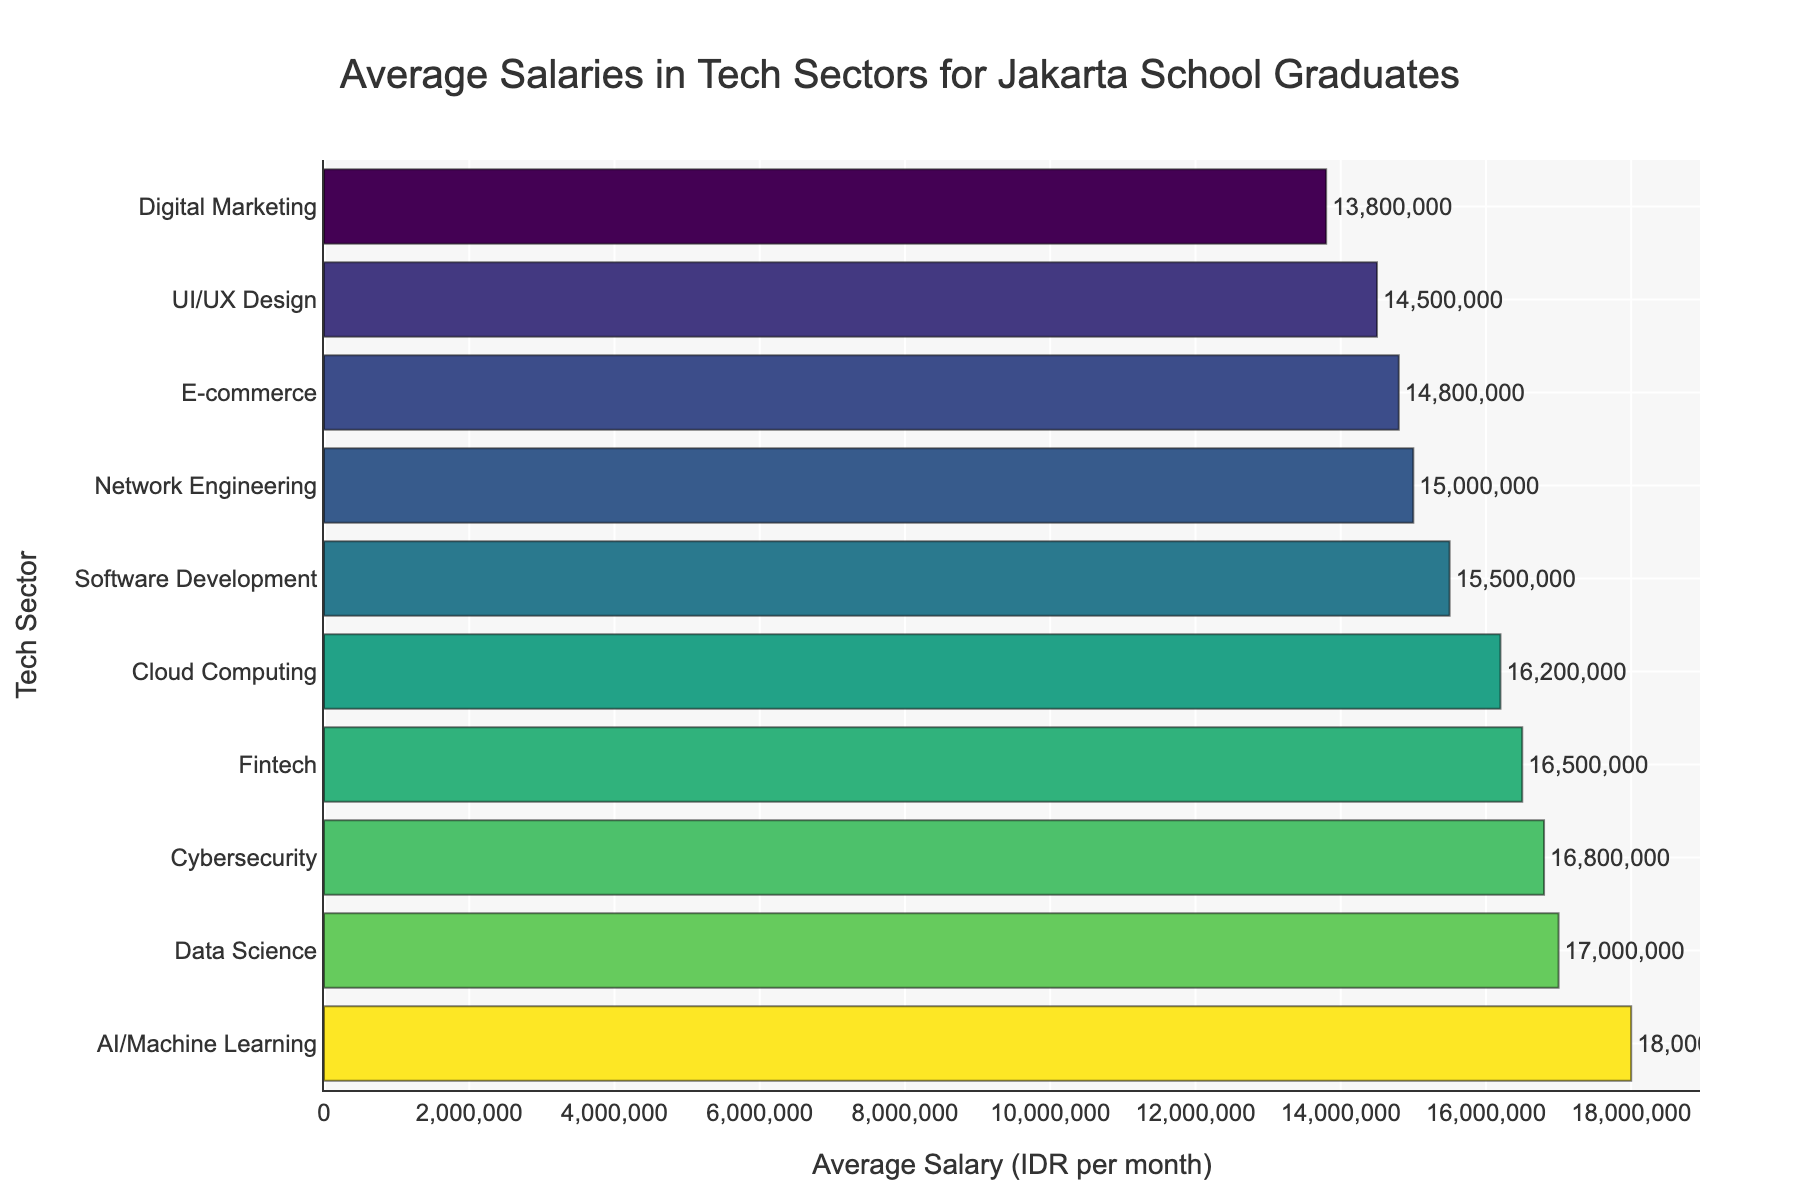Which tech sector has the highest average salary? By looking at the figure, identify the bar with the highest value on the x-axis. This will indicate the sector with the highest average salary.
Answer: AI/Machine Learning What is the difference in average salary between AI/Machine Learning and Digital Marketing sectors? Find the average salaries for both sectors from the bar chart. Subtract the average salary of Digital Marketing from that of AI/Machine Learning.
Answer: 4,200,000 IDR Which sector has a higher average salary: Cybersecurity or Network Engineering? Compare the lengths of the bars representing Cybersecurity and Network Engineering on the figure. The longer bar indicates the higher average salary.
Answer: Cybersecurity What is the sum of the average salaries for Software Development, Data Science, and Cybersecurity sectors? Sum the values of the average salaries for these three sectors as shown on the bar chart, \( 15,500,000 + 17,000,000 + 16,800,000 \).
Answer: 49,300,000 IDR Which tech sector has the shortest bar and what is its average salary? Identify the shortest bar on the chart, which visually represents the sector with the lowest average salary, and note its value.
Answer: Digital Marketing, 13,800,000 IDR How much more does an average AI/Machine Learning graduate earn compared to a UI/UX Design graduate? Subtract the average salary of UI/UX Design from AI/Machine Learning as illustrated in the chart.
Answer: 3,500,000 IDR Which sector lies between Cloud Computing and E-commerce in terms of average salary? Find the sectors listed between Cloud Computing and E-commerce on the vertical axis of the bar chart.
Answer: Network Engineering What is the mean average salary of all the tech sectors combined? Sum up the average salaries of all the tech sectors shown on the chart and divide by the number of sectors (10 in this case). \(\frac{15,500,000 + 17,000,000 + 16,800,000 + 16,200,000 + 18,000,000 + 14,500,000 + 15,000,000 + 13,800,000 + 14,800,000 + 16,500,000}{10}\).
Answer: 15,810,000 IDR How does the average salary of the Fintech sector compare to that of Cloud Computing? Compare the values of the bars representing Fintech and Cloud Computing on the chart. The higher average salary will have a longer bar.
Answer: Fintech has a higher average salary 